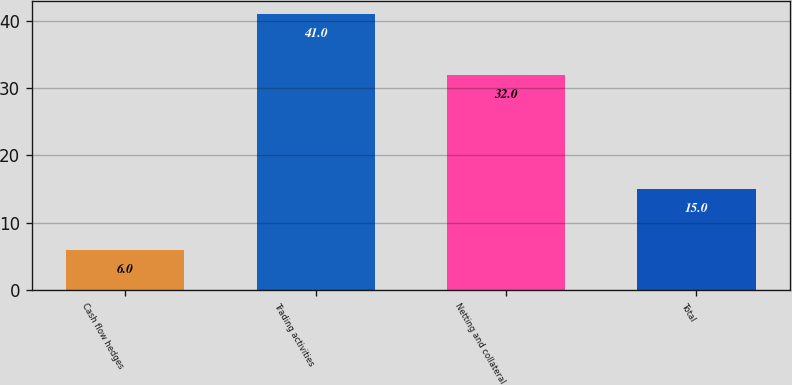<chart> <loc_0><loc_0><loc_500><loc_500><bar_chart><fcel>Cash flow hedges<fcel>Trading activities<fcel>Netting and collateral<fcel>Total<nl><fcel>6<fcel>41<fcel>32<fcel>15<nl></chart> 